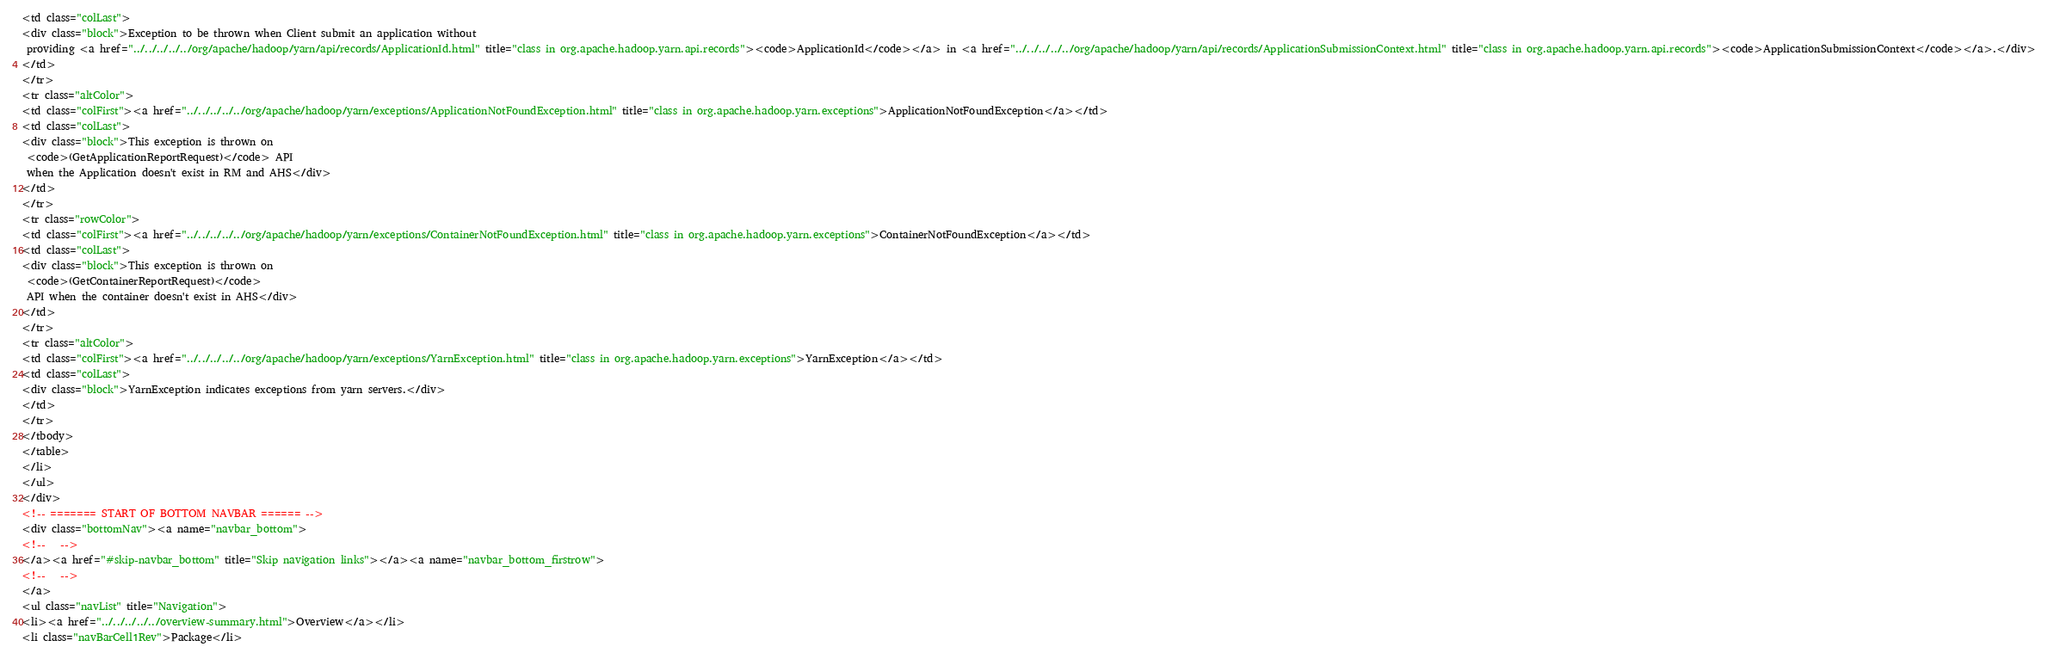Convert code to text. <code><loc_0><loc_0><loc_500><loc_500><_HTML_><td class="colLast">
<div class="block">Exception to be thrown when Client submit an application without
 providing <a href="../../../../../org/apache/hadoop/yarn/api/records/ApplicationId.html" title="class in org.apache.hadoop.yarn.api.records"><code>ApplicationId</code></a> in <a href="../../../../../org/apache/hadoop/yarn/api/records/ApplicationSubmissionContext.html" title="class in org.apache.hadoop.yarn.api.records"><code>ApplicationSubmissionContext</code></a>.</div>
</td>
</tr>
<tr class="altColor">
<td class="colFirst"><a href="../../../../../org/apache/hadoop/yarn/exceptions/ApplicationNotFoundException.html" title="class in org.apache.hadoop.yarn.exceptions">ApplicationNotFoundException</a></td>
<td class="colLast">
<div class="block">This exception is thrown on
 <code>(GetApplicationReportRequest)</code> API
 when the Application doesn't exist in RM and AHS</div>
</td>
</tr>
<tr class="rowColor">
<td class="colFirst"><a href="../../../../../org/apache/hadoop/yarn/exceptions/ContainerNotFoundException.html" title="class in org.apache.hadoop.yarn.exceptions">ContainerNotFoundException</a></td>
<td class="colLast">
<div class="block">This exception is thrown on
 <code>(GetContainerReportRequest)</code>
 API when the container doesn't exist in AHS</div>
</td>
</tr>
<tr class="altColor">
<td class="colFirst"><a href="../../../../../org/apache/hadoop/yarn/exceptions/YarnException.html" title="class in org.apache.hadoop.yarn.exceptions">YarnException</a></td>
<td class="colLast">
<div class="block">YarnException indicates exceptions from yarn servers.</div>
</td>
</tr>
</tbody>
</table>
</li>
</ul>
</div>
<!-- ======= START OF BOTTOM NAVBAR ====== -->
<div class="bottomNav"><a name="navbar_bottom">
<!--   -->
</a><a href="#skip-navbar_bottom" title="Skip navigation links"></a><a name="navbar_bottom_firstrow">
<!--   -->
</a>
<ul class="navList" title="Navigation">
<li><a href="../../../../../overview-summary.html">Overview</a></li>
<li class="navBarCell1Rev">Package</li></code> 